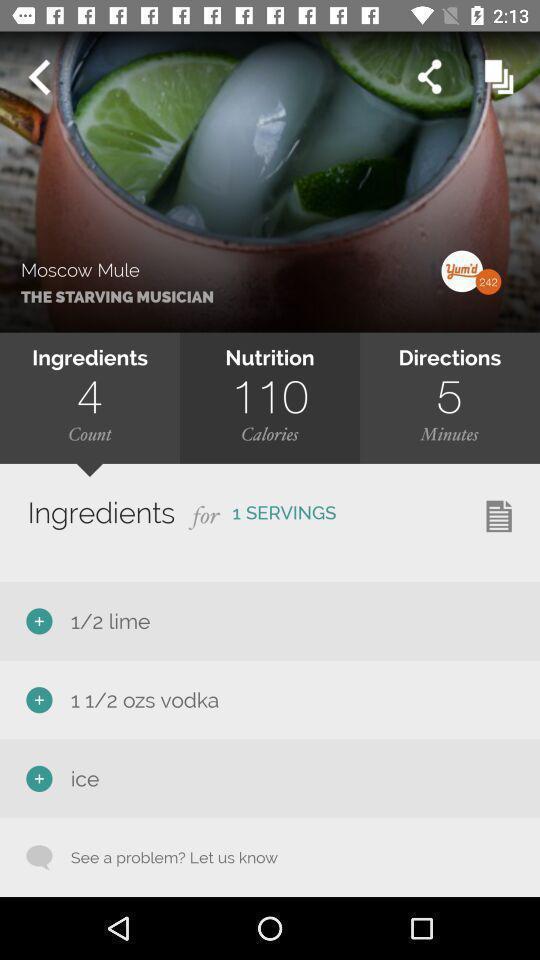Provide a textual representation of this image. Screen page displaying various details in food application. 